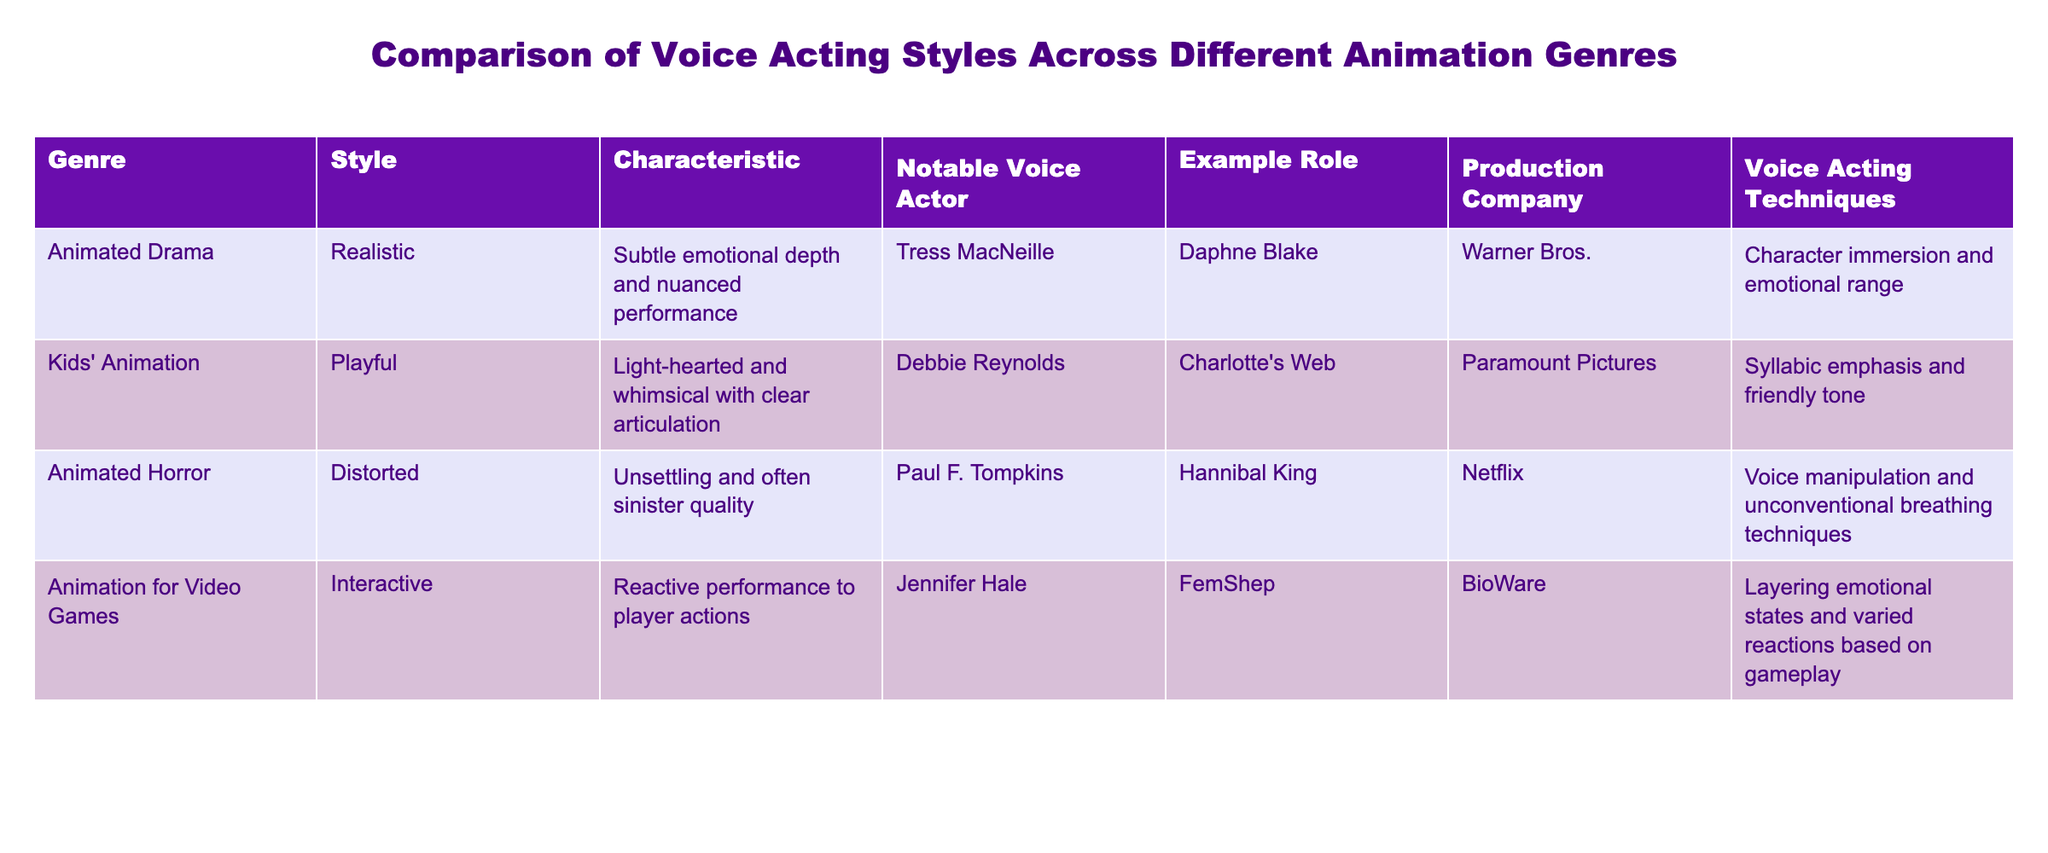What style is associated with Animated Horror? The table lists the style for Animated Horror as "Distorted."
Answer: Distorted Who voiced the character Daphne Blake? According to the table, Tress MacNeille is noted as the voice actor for Daphne Blake.
Answer: Tress MacNeille Which production company is associated with Kids' Animation? The table shows that Kids' Animation is associated with Paramount Pictures.
Answer: Paramount Pictures Which voice actor has a notable role in Animation for Video Games? The table indicates Jennifer Hale is the notable voice actor for FemShep in Animation for Video Games.
Answer: Jennifer Hale What characteristic describes the style of Animated Drama? The table states that the characteristic of Animated Drama's style is "Subtle emotional depth and nuanced performance."
Answer: Subtle emotional depth and nuanced performance List the voice acting techniques used in Kids' Animation. The table mentions that the voice acting techniques used in Kids' Animation include "Syllabic emphasis and friendly tone."
Answer: Syllabic emphasis and friendly tone What is the contrasting style for Animated Drama compared to Animated Horror? The style for Animated Drama is "Realistic," while for Animated Horror it is "Distorted," indicating a contrast in approach.
Answer: Realistic vs. Distorted Which genre emphasizes character immersion and emotional range in voice acting techniques? The table specifies that Animated Drama emphasizes character immersion and emotional range in voice acting techniques.
Answer: Animated Drama Is Paul F. Tompkins known for a heroic character in Animation for Video Games? The table shows that Paul F. Tompkins voices a character in Animated Horror, which is a villain role, not a heroic one.
Answer: No What do the notable voice actors in the table have in common concerning their roles? Analyzing the roles, all the noted actors have lent their voices to significant characters in various animation genres, each tailored to evoke specific emotions related to the genre.
Answer: They all voiced significant characters tailored to different genres 